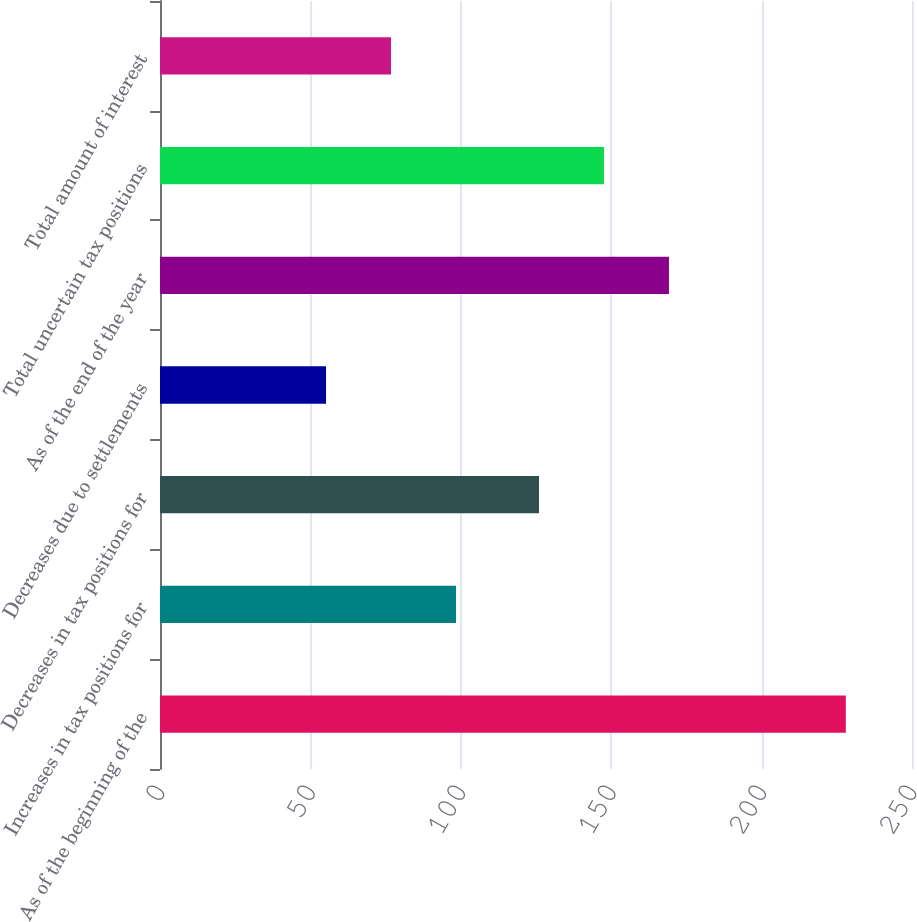Convert chart to OTSL. <chart><loc_0><loc_0><loc_500><loc_500><bar_chart><fcel>As of the beginning of the<fcel>Increases in tax positions for<fcel>Decreases in tax positions for<fcel>Decreases due to settlements<fcel>As of the end of the year<fcel>Total uncertain tax positions<fcel>Total amount of interest<nl><fcel>228<fcel>98.4<fcel>126<fcel>55.2<fcel>169.2<fcel>147.6<fcel>76.8<nl></chart> 